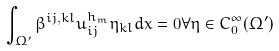Convert formula to latex. <formula><loc_0><loc_0><loc_500><loc_500>\int _ { \Omega ^ { \prime } } \beta ^ { i j , k l } u ^ { h _ { m } } _ { i j } \eta _ { k l } d x = 0 \forall \eta \in C _ { 0 } ^ { \infty } ( \Omega ^ { \prime } )</formula> 